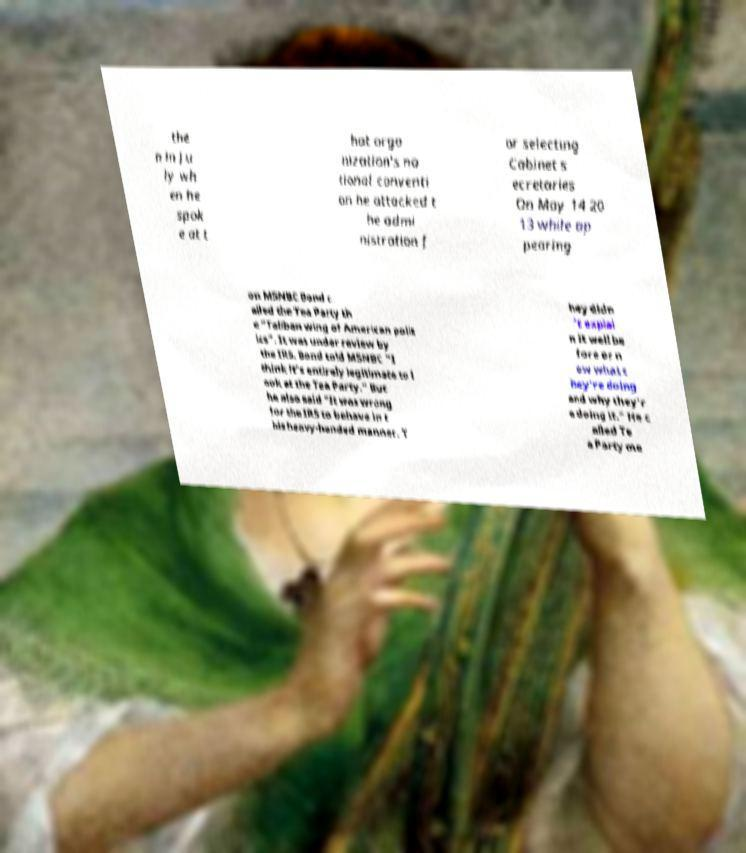Could you extract and type out the text from this image? the n in Ju ly wh en he spok e at t hat orga nization's na tional conventi on he attacked t he admi nistration f or selecting Cabinet s ecretaries On May 14 20 13 while ap pearing on MSNBC Bond c alled the Tea Party th e "Taliban wing of American polit ics". It was under review by the IRS. Bond told MSNBC "I think it's entirely legitimate to l ook at the Tea Party." But he also said "It was wrong for the IRS to behave in t his heavy-handed manner. T hey didn 't explai n it well be fore or n ow what t hey're doing and why they'r e doing it." He c alled Te a Party me 